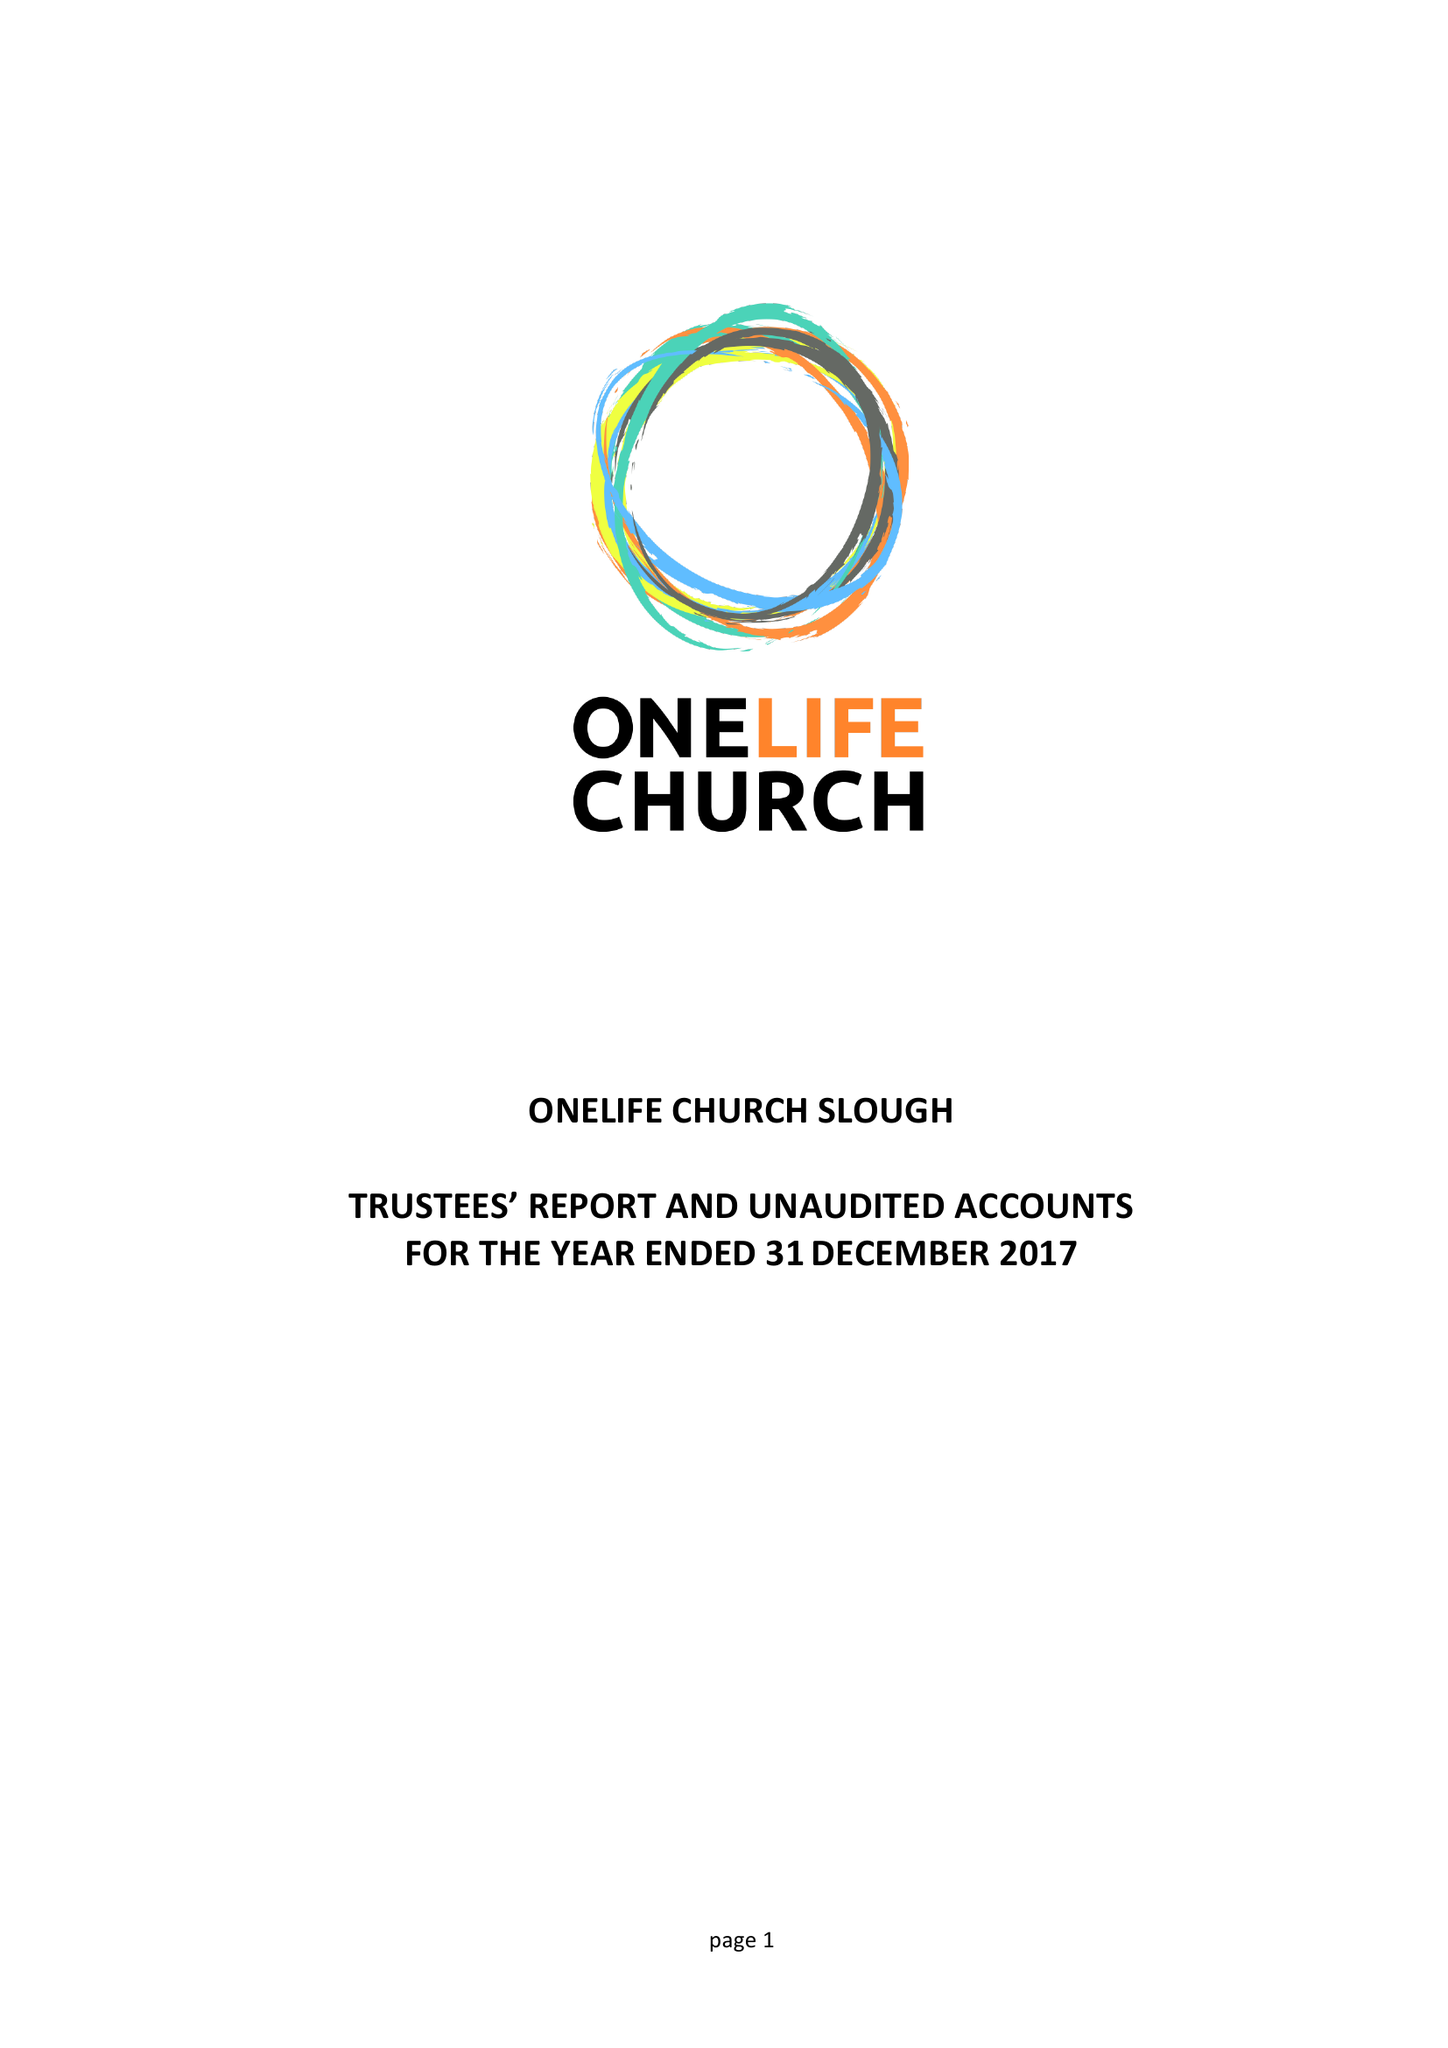What is the value for the charity_number?
Answer the question using a single word or phrase. 1156309 